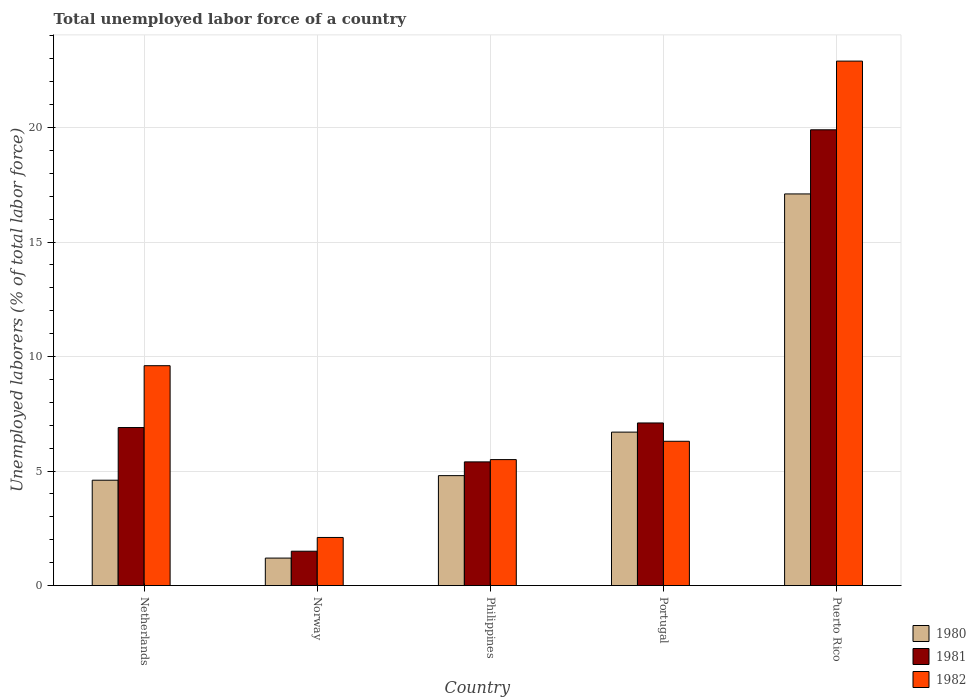Are the number of bars on each tick of the X-axis equal?
Your answer should be compact. Yes. How many bars are there on the 3rd tick from the left?
Keep it short and to the point. 3. What is the total unemployed labor force in 1981 in Norway?
Your answer should be very brief. 1.5. Across all countries, what is the maximum total unemployed labor force in 1981?
Make the answer very short. 19.9. Across all countries, what is the minimum total unemployed labor force in 1982?
Offer a terse response. 2.1. In which country was the total unemployed labor force in 1982 maximum?
Provide a short and direct response. Puerto Rico. What is the total total unemployed labor force in 1981 in the graph?
Offer a terse response. 40.8. What is the difference between the total unemployed labor force in 1982 in Netherlands and that in Philippines?
Offer a very short reply. 4.1. What is the difference between the total unemployed labor force in 1980 in Philippines and the total unemployed labor force in 1981 in Netherlands?
Make the answer very short. -2.1. What is the average total unemployed labor force in 1981 per country?
Your answer should be very brief. 8.16. What is the difference between the total unemployed labor force of/in 1981 and total unemployed labor force of/in 1980 in Norway?
Your answer should be compact. 0.3. What is the ratio of the total unemployed labor force in 1980 in Netherlands to that in Philippines?
Your answer should be compact. 0.96. Is the difference between the total unemployed labor force in 1981 in Netherlands and Portugal greater than the difference between the total unemployed labor force in 1980 in Netherlands and Portugal?
Your answer should be compact. Yes. What is the difference between the highest and the second highest total unemployed labor force in 1982?
Your response must be concise. -13.3. What is the difference between the highest and the lowest total unemployed labor force in 1981?
Make the answer very short. 18.4. What does the 3rd bar from the left in Portugal represents?
Ensure brevity in your answer.  1982. What does the 3rd bar from the right in Portugal represents?
Provide a succinct answer. 1980. What is the difference between two consecutive major ticks on the Y-axis?
Offer a terse response. 5. Are the values on the major ticks of Y-axis written in scientific E-notation?
Provide a short and direct response. No. Does the graph contain any zero values?
Provide a short and direct response. No. Where does the legend appear in the graph?
Ensure brevity in your answer.  Bottom right. What is the title of the graph?
Your response must be concise. Total unemployed labor force of a country. Does "1991" appear as one of the legend labels in the graph?
Offer a terse response. No. What is the label or title of the Y-axis?
Provide a short and direct response. Unemployed laborers (% of total labor force). What is the Unemployed laborers (% of total labor force) in 1980 in Netherlands?
Provide a succinct answer. 4.6. What is the Unemployed laborers (% of total labor force) in 1981 in Netherlands?
Keep it short and to the point. 6.9. What is the Unemployed laborers (% of total labor force) in 1982 in Netherlands?
Make the answer very short. 9.6. What is the Unemployed laborers (% of total labor force) in 1980 in Norway?
Provide a short and direct response. 1.2. What is the Unemployed laborers (% of total labor force) of 1982 in Norway?
Provide a succinct answer. 2.1. What is the Unemployed laborers (% of total labor force) in 1980 in Philippines?
Ensure brevity in your answer.  4.8. What is the Unemployed laborers (% of total labor force) of 1981 in Philippines?
Your answer should be very brief. 5.4. What is the Unemployed laborers (% of total labor force) of 1982 in Philippines?
Give a very brief answer. 5.5. What is the Unemployed laborers (% of total labor force) in 1980 in Portugal?
Ensure brevity in your answer.  6.7. What is the Unemployed laborers (% of total labor force) of 1981 in Portugal?
Keep it short and to the point. 7.1. What is the Unemployed laborers (% of total labor force) in 1982 in Portugal?
Your answer should be very brief. 6.3. What is the Unemployed laborers (% of total labor force) in 1980 in Puerto Rico?
Make the answer very short. 17.1. What is the Unemployed laborers (% of total labor force) in 1981 in Puerto Rico?
Your answer should be compact. 19.9. What is the Unemployed laborers (% of total labor force) of 1982 in Puerto Rico?
Offer a terse response. 22.9. Across all countries, what is the maximum Unemployed laborers (% of total labor force) of 1980?
Offer a terse response. 17.1. Across all countries, what is the maximum Unemployed laborers (% of total labor force) in 1981?
Offer a terse response. 19.9. Across all countries, what is the maximum Unemployed laborers (% of total labor force) of 1982?
Give a very brief answer. 22.9. Across all countries, what is the minimum Unemployed laborers (% of total labor force) in 1980?
Your answer should be very brief. 1.2. Across all countries, what is the minimum Unemployed laborers (% of total labor force) in 1982?
Offer a terse response. 2.1. What is the total Unemployed laborers (% of total labor force) in 1980 in the graph?
Give a very brief answer. 34.4. What is the total Unemployed laborers (% of total labor force) in 1981 in the graph?
Your answer should be very brief. 40.8. What is the total Unemployed laborers (% of total labor force) of 1982 in the graph?
Your answer should be very brief. 46.4. What is the difference between the Unemployed laborers (% of total labor force) of 1981 in Netherlands and that in Norway?
Provide a short and direct response. 5.4. What is the difference between the Unemployed laborers (% of total labor force) of 1982 in Netherlands and that in Norway?
Keep it short and to the point. 7.5. What is the difference between the Unemployed laborers (% of total labor force) in 1980 in Netherlands and that in Philippines?
Your response must be concise. -0.2. What is the difference between the Unemployed laborers (% of total labor force) of 1981 in Netherlands and that in Philippines?
Provide a succinct answer. 1.5. What is the difference between the Unemployed laborers (% of total labor force) of 1982 in Netherlands and that in Philippines?
Your answer should be very brief. 4.1. What is the difference between the Unemployed laborers (% of total labor force) of 1981 in Netherlands and that in Portugal?
Your response must be concise. -0.2. What is the difference between the Unemployed laborers (% of total labor force) of 1980 in Netherlands and that in Puerto Rico?
Make the answer very short. -12.5. What is the difference between the Unemployed laborers (% of total labor force) in 1981 in Netherlands and that in Puerto Rico?
Your response must be concise. -13. What is the difference between the Unemployed laborers (% of total labor force) of 1982 in Netherlands and that in Puerto Rico?
Offer a terse response. -13.3. What is the difference between the Unemployed laborers (% of total labor force) of 1980 in Norway and that in Portugal?
Your response must be concise. -5.5. What is the difference between the Unemployed laborers (% of total labor force) in 1982 in Norway and that in Portugal?
Provide a succinct answer. -4.2. What is the difference between the Unemployed laborers (% of total labor force) of 1980 in Norway and that in Puerto Rico?
Give a very brief answer. -15.9. What is the difference between the Unemployed laborers (% of total labor force) in 1981 in Norway and that in Puerto Rico?
Give a very brief answer. -18.4. What is the difference between the Unemployed laborers (% of total labor force) of 1982 in Norway and that in Puerto Rico?
Make the answer very short. -20.8. What is the difference between the Unemployed laborers (% of total labor force) of 1980 in Philippines and that in Portugal?
Your answer should be compact. -1.9. What is the difference between the Unemployed laborers (% of total labor force) in 1980 in Philippines and that in Puerto Rico?
Offer a very short reply. -12.3. What is the difference between the Unemployed laborers (% of total labor force) in 1981 in Philippines and that in Puerto Rico?
Provide a short and direct response. -14.5. What is the difference between the Unemployed laborers (% of total labor force) in 1982 in Philippines and that in Puerto Rico?
Your answer should be compact. -17.4. What is the difference between the Unemployed laborers (% of total labor force) of 1980 in Portugal and that in Puerto Rico?
Your response must be concise. -10.4. What is the difference between the Unemployed laborers (% of total labor force) in 1981 in Portugal and that in Puerto Rico?
Offer a very short reply. -12.8. What is the difference between the Unemployed laborers (% of total labor force) in 1982 in Portugal and that in Puerto Rico?
Offer a terse response. -16.6. What is the difference between the Unemployed laborers (% of total labor force) of 1980 in Netherlands and the Unemployed laborers (% of total labor force) of 1981 in Norway?
Offer a terse response. 3.1. What is the difference between the Unemployed laborers (% of total labor force) of 1981 in Netherlands and the Unemployed laborers (% of total labor force) of 1982 in Norway?
Provide a short and direct response. 4.8. What is the difference between the Unemployed laborers (% of total labor force) in 1980 in Netherlands and the Unemployed laborers (% of total labor force) in 1981 in Philippines?
Provide a succinct answer. -0.8. What is the difference between the Unemployed laborers (% of total labor force) of 1980 in Netherlands and the Unemployed laborers (% of total labor force) of 1982 in Portugal?
Your answer should be compact. -1.7. What is the difference between the Unemployed laborers (% of total labor force) of 1981 in Netherlands and the Unemployed laborers (% of total labor force) of 1982 in Portugal?
Offer a very short reply. 0.6. What is the difference between the Unemployed laborers (% of total labor force) of 1980 in Netherlands and the Unemployed laborers (% of total labor force) of 1981 in Puerto Rico?
Provide a succinct answer. -15.3. What is the difference between the Unemployed laborers (% of total labor force) in 1980 in Netherlands and the Unemployed laborers (% of total labor force) in 1982 in Puerto Rico?
Offer a terse response. -18.3. What is the difference between the Unemployed laborers (% of total labor force) of 1981 in Norway and the Unemployed laborers (% of total labor force) of 1982 in Philippines?
Offer a terse response. -4. What is the difference between the Unemployed laborers (% of total labor force) in 1981 in Norway and the Unemployed laborers (% of total labor force) in 1982 in Portugal?
Keep it short and to the point. -4.8. What is the difference between the Unemployed laborers (% of total labor force) in 1980 in Norway and the Unemployed laborers (% of total labor force) in 1981 in Puerto Rico?
Provide a short and direct response. -18.7. What is the difference between the Unemployed laborers (% of total labor force) in 1980 in Norway and the Unemployed laborers (% of total labor force) in 1982 in Puerto Rico?
Keep it short and to the point. -21.7. What is the difference between the Unemployed laborers (% of total labor force) of 1981 in Norway and the Unemployed laborers (% of total labor force) of 1982 in Puerto Rico?
Provide a succinct answer. -21.4. What is the difference between the Unemployed laborers (% of total labor force) in 1981 in Philippines and the Unemployed laborers (% of total labor force) in 1982 in Portugal?
Give a very brief answer. -0.9. What is the difference between the Unemployed laborers (% of total labor force) of 1980 in Philippines and the Unemployed laborers (% of total labor force) of 1981 in Puerto Rico?
Your answer should be very brief. -15.1. What is the difference between the Unemployed laborers (% of total labor force) of 1980 in Philippines and the Unemployed laborers (% of total labor force) of 1982 in Puerto Rico?
Your response must be concise. -18.1. What is the difference between the Unemployed laborers (% of total labor force) of 1981 in Philippines and the Unemployed laborers (% of total labor force) of 1982 in Puerto Rico?
Offer a very short reply. -17.5. What is the difference between the Unemployed laborers (% of total labor force) in 1980 in Portugal and the Unemployed laborers (% of total labor force) in 1981 in Puerto Rico?
Provide a succinct answer. -13.2. What is the difference between the Unemployed laborers (% of total labor force) of 1980 in Portugal and the Unemployed laborers (% of total labor force) of 1982 in Puerto Rico?
Give a very brief answer. -16.2. What is the difference between the Unemployed laborers (% of total labor force) of 1981 in Portugal and the Unemployed laborers (% of total labor force) of 1982 in Puerto Rico?
Offer a very short reply. -15.8. What is the average Unemployed laborers (% of total labor force) of 1980 per country?
Offer a terse response. 6.88. What is the average Unemployed laborers (% of total labor force) of 1981 per country?
Ensure brevity in your answer.  8.16. What is the average Unemployed laborers (% of total labor force) in 1982 per country?
Keep it short and to the point. 9.28. What is the difference between the Unemployed laborers (% of total labor force) in 1980 and Unemployed laborers (% of total labor force) in 1982 in Netherlands?
Keep it short and to the point. -5. What is the difference between the Unemployed laborers (% of total labor force) of 1981 and Unemployed laborers (% of total labor force) of 1982 in Netherlands?
Keep it short and to the point. -2.7. What is the difference between the Unemployed laborers (% of total labor force) of 1981 and Unemployed laborers (% of total labor force) of 1982 in Norway?
Offer a very short reply. -0.6. What is the difference between the Unemployed laborers (% of total labor force) of 1980 and Unemployed laborers (% of total labor force) of 1982 in Philippines?
Your response must be concise. -0.7. What is the difference between the Unemployed laborers (% of total labor force) of 1981 and Unemployed laborers (% of total labor force) of 1982 in Philippines?
Provide a succinct answer. -0.1. What is the difference between the Unemployed laborers (% of total labor force) of 1980 and Unemployed laborers (% of total labor force) of 1981 in Portugal?
Your answer should be compact. -0.4. What is the difference between the Unemployed laborers (% of total labor force) in 1981 and Unemployed laborers (% of total labor force) in 1982 in Portugal?
Provide a short and direct response. 0.8. What is the ratio of the Unemployed laborers (% of total labor force) of 1980 in Netherlands to that in Norway?
Offer a terse response. 3.83. What is the ratio of the Unemployed laborers (% of total labor force) in 1982 in Netherlands to that in Norway?
Make the answer very short. 4.57. What is the ratio of the Unemployed laborers (% of total labor force) in 1981 in Netherlands to that in Philippines?
Provide a succinct answer. 1.28. What is the ratio of the Unemployed laborers (% of total labor force) of 1982 in Netherlands to that in Philippines?
Offer a very short reply. 1.75. What is the ratio of the Unemployed laborers (% of total labor force) in 1980 in Netherlands to that in Portugal?
Give a very brief answer. 0.69. What is the ratio of the Unemployed laborers (% of total labor force) of 1981 in Netherlands to that in Portugal?
Provide a short and direct response. 0.97. What is the ratio of the Unemployed laborers (% of total labor force) in 1982 in Netherlands to that in Portugal?
Keep it short and to the point. 1.52. What is the ratio of the Unemployed laborers (% of total labor force) in 1980 in Netherlands to that in Puerto Rico?
Your answer should be very brief. 0.27. What is the ratio of the Unemployed laborers (% of total labor force) of 1981 in Netherlands to that in Puerto Rico?
Offer a very short reply. 0.35. What is the ratio of the Unemployed laborers (% of total labor force) in 1982 in Netherlands to that in Puerto Rico?
Keep it short and to the point. 0.42. What is the ratio of the Unemployed laborers (% of total labor force) of 1980 in Norway to that in Philippines?
Your answer should be compact. 0.25. What is the ratio of the Unemployed laborers (% of total labor force) of 1981 in Norway to that in Philippines?
Offer a very short reply. 0.28. What is the ratio of the Unemployed laborers (% of total labor force) in 1982 in Norway to that in Philippines?
Keep it short and to the point. 0.38. What is the ratio of the Unemployed laborers (% of total labor force) in 1980 in Norway to that in Portugal?
Provide a short and direct response. 0.18. What is the ratio of the Unemployed laborers (% of total labor force) of 1981 in Norway to that in Portugal?
Offer a very short reply. 0.21. What is the ratio of the Unemployed laborers (% of total labor force) of 1980 in Norway to that in Puerto Rico?
Give a very brief answer. 0.07. What is the ratio of the Unemployed laborers (% of total labor force) of 1981 in Norway to that in Puerto Rico?
Your answer should be very brief. 0.08. What is the ratio of the Unemployed laborers (% of total labor force) in 1982 in Norway to that in Puerto Rico?
Your response must be concise. 0.09. What is the ratio of the Unemployed laborers (% of total labor force) of 1980 in Philippines to that in Portugal?
Provide a short and direct response. 0.72. What is the ratio of the Unemployed laborers (% of total labor force) in 1981 in Philippines to that in Portugal?
Offer a very short reply. 0.76. What is the ratio of the Unemployed laborers (% of total labor force) in 1982 in Philippines to that in Portugal?
Make the answer very short. 0.87. What is the ratio of the Unemployed laborers (% of total labor force) of 1980 in Philippines to that in Puerto Rico?
Keep it short and to the point. 0.28. What is the ratio of the Unemployed laborers (% of total labor force) of 1981 in Philippines to that in Puerto Rico?
Provide a short and direct response. 0.27. What is the ratio of the Unemployed laborers (% of total labor force) in 1982 in Philippines to that in Puerto Rico?
Offer a terse response. 0.24. What is the ratio of the Unemployed laborers (% of total labor force) in 1980 in Portugal to that in Puerto Rico?
Your answer should be very brief. 0.39. What is the ratio of the Unemployed laborers (% of total labor force) in 1981 in Portugal to that in Puerto Rico?
Ensure brevity in your answer.  0.36. What is the ratio of the Unemployed laborers (% of total labor force) in 1982 in Portugal to that in Puerto Rico?
Your answer should be very brief. 0.28. What is the difference between the highest and the second highest Unemployed laborers (% of total labor force) of 1982?
Keep it short and to the point. 13.3. What is the difference between the highest and the lowest Unemployed laborers (% of total labor force) in 1982?
Provide a short and direct response. 20.8. 